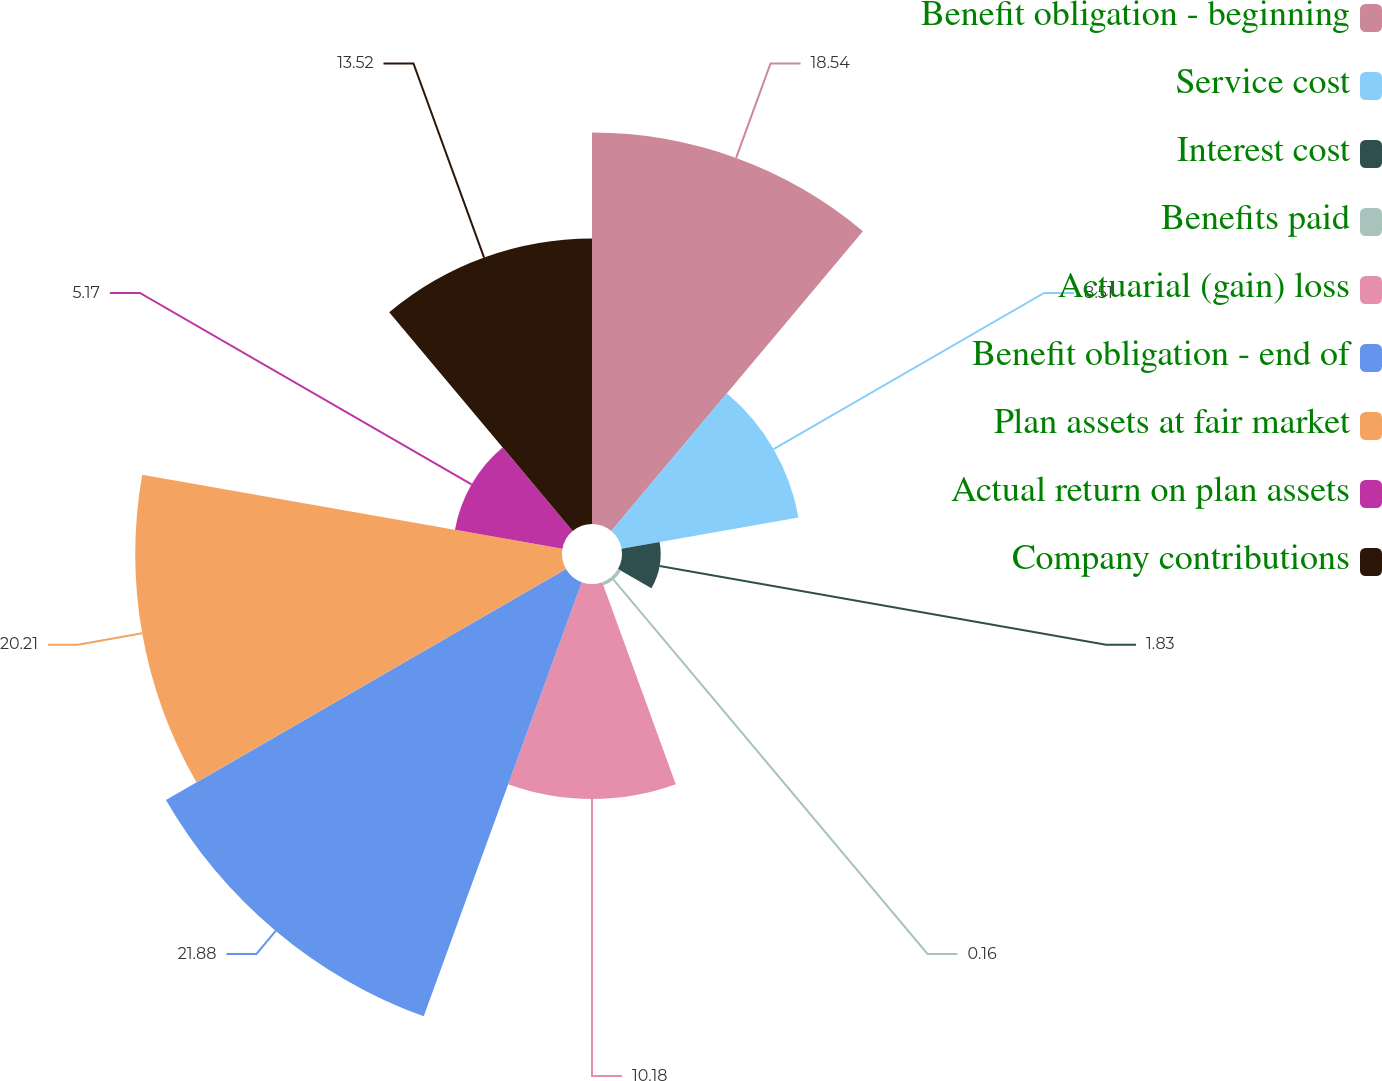Convert chart to OTSL. <chart><loc_0><loc_0><loc_500><loc_500><pie_chart><fcel>Benefit obligation - beginning<fcel>Service cost<fcel>Interest cost<fcel>Benefits paid<fcel>Actuarial (gain) loss<fcel>Benefit obligation - end of<fcel>Plan assets at fair market<fcel>Actual return on plan assets<fcel>Company contributions<nl><fcel>18.54%<fcel>8.51%<fcel>1.83%<fcel>0.16%<fcel>10.18%<fcel>21.88%<fcel>20.21%<fcel>5.17%<fcel>13.52%<nl></chart> 